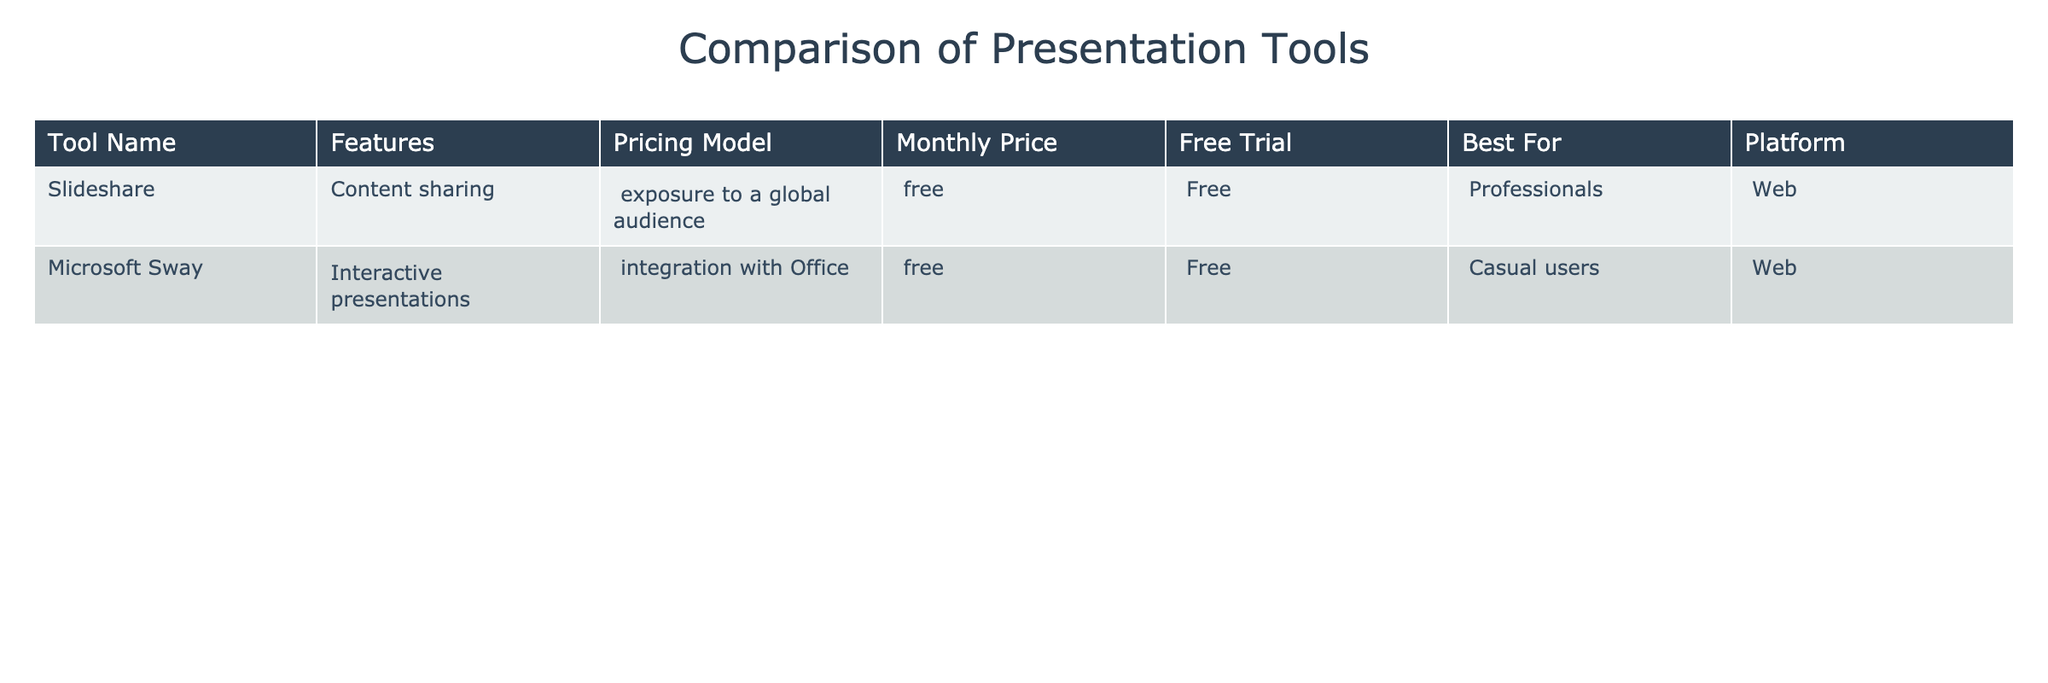What is the pricing model for Microsoft Sway? The pricing model for Microsoft Sway is indicated in the table under the "Pricing Model" column, which shows "free" for Microsoft Sway.
Answer: free Which tool is best for professionals according to the table? By examining the "Best For" column, it can be confirmed that Slideshare is labeled as best for professionals.
Answer: Slideshare Does Slideshare have a free trial? The "Free Trial" column for Slideshare indicates "Free," confirming that it does have a free trial available.
Answer: Yes Which platform is used by Microsoft Sway? In the table, the "Platform" column for Microsoft Sway indicates that it is a web-based tool.
Answer: Web How much does Slideshare cost per month? The "Monthly Price" column shows that Slideshare's monthly price is listed as "Free," meaning it does not have a cost associated.
Answer: Free Are both tools suitable for casual users? The "Best For" column lists Slideshare for professionals and Microsoft Sway for casual users, meaning only Microsoft Sway is suitable for casual users.
Answer: No What is the difference in monthly price between the two tools? Since both tools are listed as free, the difference in pricing is zero; (0) for Slideshare and (0) for Microsoft Sway results in 0.
Answer: 0 Which tool offers content sharing features? By looking at the "Features" column, it is apparent that Slideshare offers content sharing features.
Answer: Slideshare Is there any tool in the table that is paid? Both tools are mentioned in the table with free pricing models, indicating that there are no paid tools listed.
Answer: No Which tool can be integrated with Office applications? The features listed in the table specify that Microsoft Sway offers integration with Office applications.
Answer: Microsoft Sway 